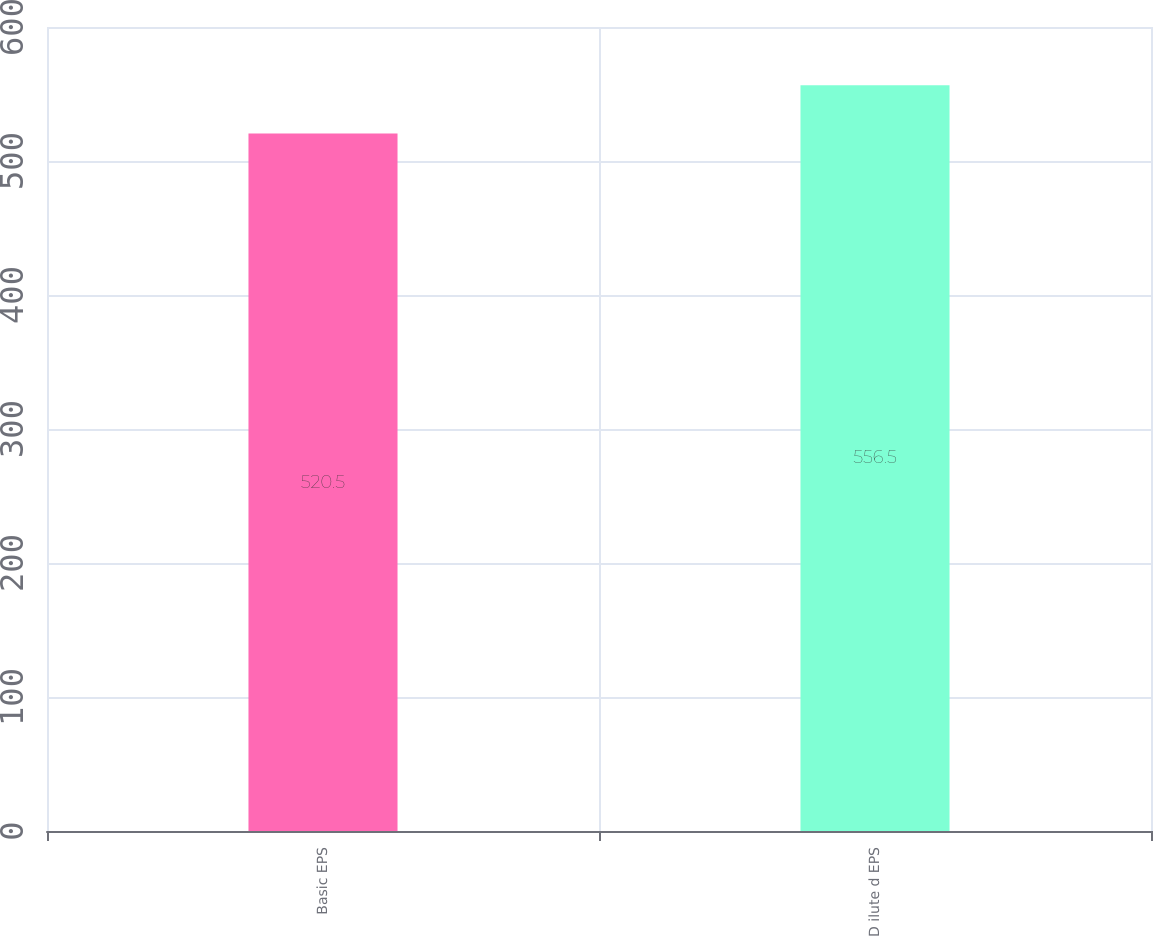<chart> <loc_0><loc_0><loc_500><loc_500><bar_chart><fcel>Basic EPS<fcel>D ilute d EPS<nl><fcel>520.5<fcel>556.5<nl></chart> 